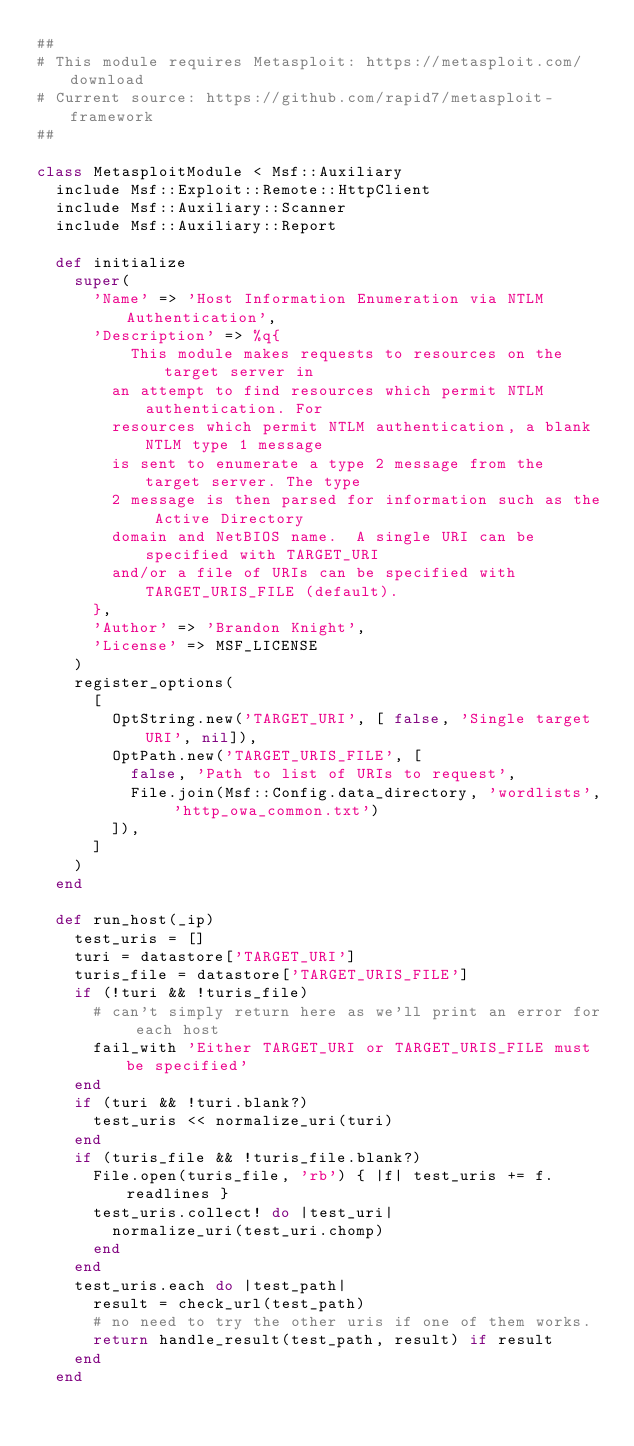Convert code to text. <code><loc_0><loc_0><loc_500><loc_500><_Ruby_>##
# This module requires Metasploit: https://metasploit.com/download
# Current source: https://github.com/rapid7/metasploit-framework
##

class MetasploitModule < Msf::Auxiliary
  include Msf::Exploit::Remote::HttpClient
  include Msf::Auxiliary::Scanner
  include Msf::Auxiliary::Report

  def initialize
    super(
      'Name' => 'Host Information Enumeration via NTLM Authentication',
      'Description' => %q{
          This module makes requests to resources on the target server in
        an attempt to find resources which permit NTLM authentication. For
        resources which permit NTLM authentication, a blank NTLM type 1 message
        is sent to enumerate a type 2 message from the target server. The type
        2 message is then parsed for information such as the Active Directory
        domain and NetBIOS name.  A single URI can be specified with TARGET_URI
        and/or a file of URIs can be specified with TARGET_URIS_FILE (default).
      },
      'Author' => 'Brandon Knight',
      'License' => MSF_LICENSE
    )
    register_options(
      [
        OptString.new('TARGET_URI', [ false, 'Single target URI', nil]),
        OptPath.new('TARGET_URIS_FILE', [
          false, 'Path to list of URIs to request',
          File.join(Msf::Config.data_directory, 'wordlists', 'http_owa_common.txt')
        ]),
      ]
    )
  end

  def run_host(_ip)
    test_uris = []
    turi = datastore['TARGET_URI']
    turis_file = datastore['TARGET_URIS_FILE']
    if (!turi && !turis_file)
      # can't simply return here as we'll print an error for each host
      fail_with 'Either TARGET_URI or TARGET_URIS_FILE must be specified'
    end
    if (turi && !turi.blank?)
      test_uris << normalize_uri(turi)
    end
    if (turis_file && !turis_file.blank?)
      File.open(turis_file, 'rb') { |f| test_uris += f.readlines }
      test_uris.collect! do |test_uri|
        normalize_uri(test_uri.chomp)
      end
    end
    test_uris.each do |test_path|
      result = check_url(test_path)
      # no need to try the other uris if one of them works.
      return handle_result(test_path, result) if result
    end
  end
</code> 